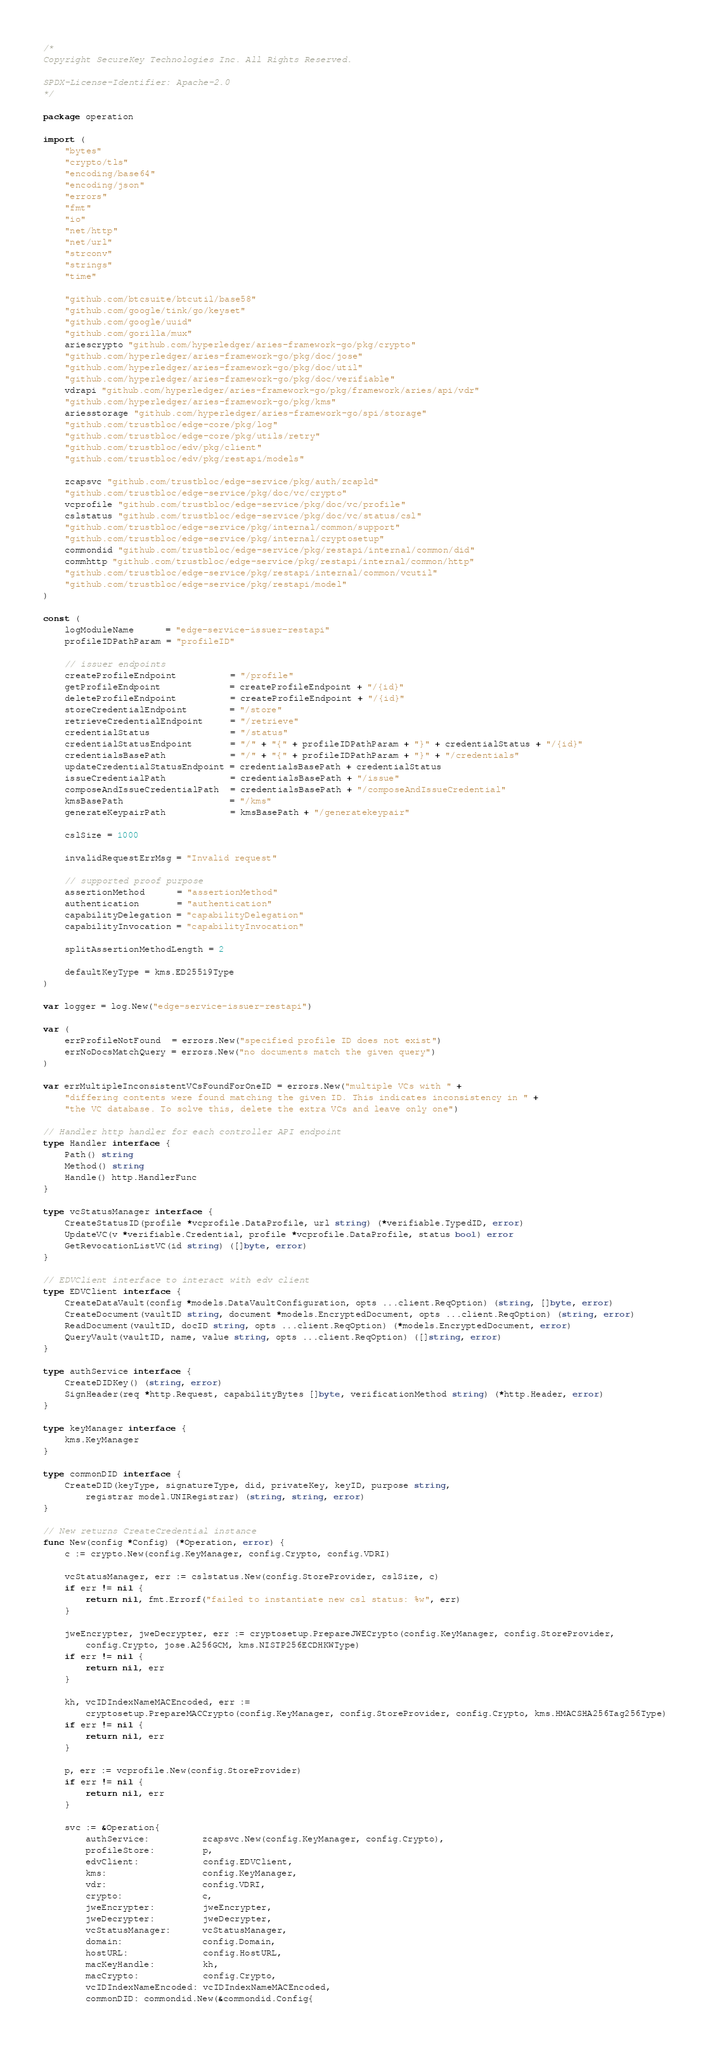<code> <loc_0><loc_0><loc_500><loc_500><_Go_>/*
Copyright SecureKey Technologies Inc. All Rights Reserved.

SPDX-License-Identifier: Apache-2.0
*/

package operation

import (
	"bytes"
	"crypto/tls"
	"encoding/base64"
	"encoding/json"
	"errors"
	"fmt"
	"io"
	"net/http"
	"net/url"
	"strconv"
	"strings"
	"time"

	"github.com/btcsuite/btcutil/base58"
	"github.com/google/tink/go/keyset"
	"github.com/google/uuid"
	"github.com/gorilla/mux"
	ariescrypto "github.com/hyperledger/aries-framework-go/pkg/crypto"
	"github.com/hyperledger/aries-framework-go/pkg/doc/jose"
	"github.com/hyperledger/aries-framework-go/pkg/doc/util"
	"github.com/hyperledger/aries-framework-go/pkg/doc/verifiable"
	vdrapi "github.com/hyperledger/aries-framework-go/pkg/framework/aries/api/vdr"
	"github.com/hyperledger/aries-framework-go/pkg/kms"
	ariesstorage "github.com/hyperledger/aries-framework-go/spi/storage"
	"github.com/trustbloc/edge-core/pkg/log"
	"github.com/trustbloc/edge-core/pkg/utils/retry"
	"github.com/trustbloc/edv/pkg/client"
	"github.com/trustbloc/edv/pkg/restapi/models"

	zcapsvc "github.com/trustbloc/edge-service/pkg/auth/zcapld"
	"github.com/trustbloc/edge-service/pkg/doc/vc/crypto"
	vcprofile "github.com/trustbloc/edge-service/pkg/doc/vc/profile"
	cslstatus "github.com/trustbloc/edge-service/pkg/doc/vc/status/csl"
	"github.com/trustbloc/edge-service/pkg/internal/common/support"
	"github.com/trustbloc/edge-service/pkg/internal/cryptosetup"
	commondid "github.com/trustbloc/edge-service/pkg/restapi/internal/common/did"
	commhttp "github.com/trustbloc/edge-service/pkg/restapi/internal/common/http"
	"github.com/trustbloc/edge-service/pkg/restapi/internal/common/vcutil"
	"github.com/trustbloc/edge-service/pkg/restapi/model"
)

const (
	logModuleName      = "edge-service-issuer-restapi"
	profileIDPathParam = "profileID"

	// issuer endpoints
	createProfileEndpoint          = "/profile"
	getProfileEndpoint             = createProfileEndpoint + "/{id}"
	deleteProfileEndpoint          = createProfileEndpoint + "/{id}"
	storeCredentialEndpoint        = "/store"
	retrieveCredentialEndpoint     = "/retrieve"
	credentialStatus               = "/status"
	credentialStatusEndpoint       = "/" + "{" + profileIDPathParam + "}" + credentialStatus + "/{id}"
	credentialsBasePath            = "/" + "{" + profileIDPathParam + "}" + "/credentials"
	updateCredentialStatusEndpoint = credentialsBasePath + credentialStatus
	issueCredentialPath            = credentialsBasePath + "/issue"
	composeAndIssueCredentialPath  = credentialsBasePath + "/composeAndIssueCredential"
	kmsBasePath                    = "/kms"
	generateKeypairPath            = kmsBasePath + "/generatekeypair"

	cslSize = 1000

	invalidRequestErrMsg = "Invalid request"

	// supported proof purpose
	assertionMethod      = "assertionMethod"
	authentication       = "authentication"
	capabilityDelegation = "capabilityDelegation"
	capabilityInvocation = "capabilityInvocation"

	splitAssertionMethodLength = 2

	defaultKeyType = kms.ED25519Type
)

var logger = log.New("edge-service-issuer-restapi")

var (
	errProfileNotFound  = errors.New("specified profile ID does not exist")
	errNoDocsMatchQuery = errors.New("no documents match the given query")
)

var errMultipleInconsistentVCsFoundForOneID = errors.New("multiple VCs with " +
	"differing contents were found matching the given ID. This indicates inconsistency in " +
	"the VC database. To solve this, delete the extra VCs and leave only one")

// Handler http handler for each controller API endpoint
type Handler interface {
	Path() string
	Method() string
	Handle() http.HandlerFunc
}

type vcStatusManager interface {
	CreateStatusID(profile *vcprofile.DataProfile, url string) (*verifiable.TypedID, error)
	UpdateVC(v *verifiable.Credential, profile *vcprofile.DataProfile, status bool) error
	GetRevocationListVC(id string) ([]byte, error)
}

// EDVClient interface to interact with edv client
type EDVClient interface {
	CreateDataVault(config *models.DataVaultConfiguration, opts ...client.ReqOption) (string, []byte, error)
	CreateDocument(vaultID string, document *models.EncryptedDocument, opts ...client.ReqOption) (string, error)
	ReadDocument(vaultID, docID string, opts ...client.ReqOption) (*models.EncryptedDocument, error)
	QueryVault(vaultID, name, value string, opts ...client.ReqOption) ([]string, error)
}

type authService interface {
	CreateDIDKey() (string, error)
	SignHeader(req *http.Request, capabilityBytes []byte, verificationMethod string) (*http.Header, error)
}

type keyManager interface {
	kms.KeyManager
}

type commonDID interface {
	CreateDID(keyType, signatureType, did, privateKey, keyID, purpose string,
		registrar model.UNIRegistrar) (string, string, error)
}

// New returns CreateCredential instance
func New(config *Config) (*Operation, error) {
	c := crypto.New(config.KeyManager, config.Crypto, config.VDRI)

	vcStatusManager, err := cslstatus.New(config.StoreProvider, cslSize, c)
	if err != nil {
		return nil, fmt.Errorf("failed to instantiate new csl status: %w", err)
	}

	jweEncrypter, jweDecrypter, err := cryptosetup.PrepareJWECrypto(config.KeyManager, config.StoreProvider,
		config.Crypto, jose.A256GCM, kms.NISTP256ECDHKWType)
	if err != nil {
		return nil, err
	}

	kh, vcIDIndexNameMACEncoded, err :=
		cryptosetup.PrepareMACCrypto(config.KeyManager, config.StoreProvider, config.Crypto, kms.HMACSHA256Tag256Type)
	if err != nil {
		return nil, err
	}

	p, err := vcprofile.New(config.StoreProvider)
	if err != nil {
		return nil, err
	}

	svc := &Operation{
		authService:          zcapsvc.New(config.KeyManager, config.Crypto),
		profileStore:         p,
		edvClient:            config.EDVClient,
		kms:                  config.KeyManager,
		vdr:                  config.VDRI,
		crypto:               c,
		jweEncrypter:         jweEncrypter,
		jweDecrypter:         jweDecrypter,
		vcStatusManager:      vcStatusManager,
		domain:               config.Domain,
		hostURL:              config.HostURL,
		macKeyHandle:         kh,
		macCrypto:            config.Crypto,
		vcIDIndexNameEncoded: vcIDIndexNameMACEncoded,
		commonDID: commondid.New(&commondid.Config{</code> 